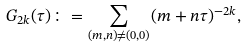Convert formula to latex. <formula><loc_0><loc_0><loc_500><loc_500>G _ { 2 k } ( \tau ) \colon = \sum _ { ( m , n ) \neq ( 0 , 0 ) } ( m + n \tau ) ^ { - 2 k } ,</formula> 